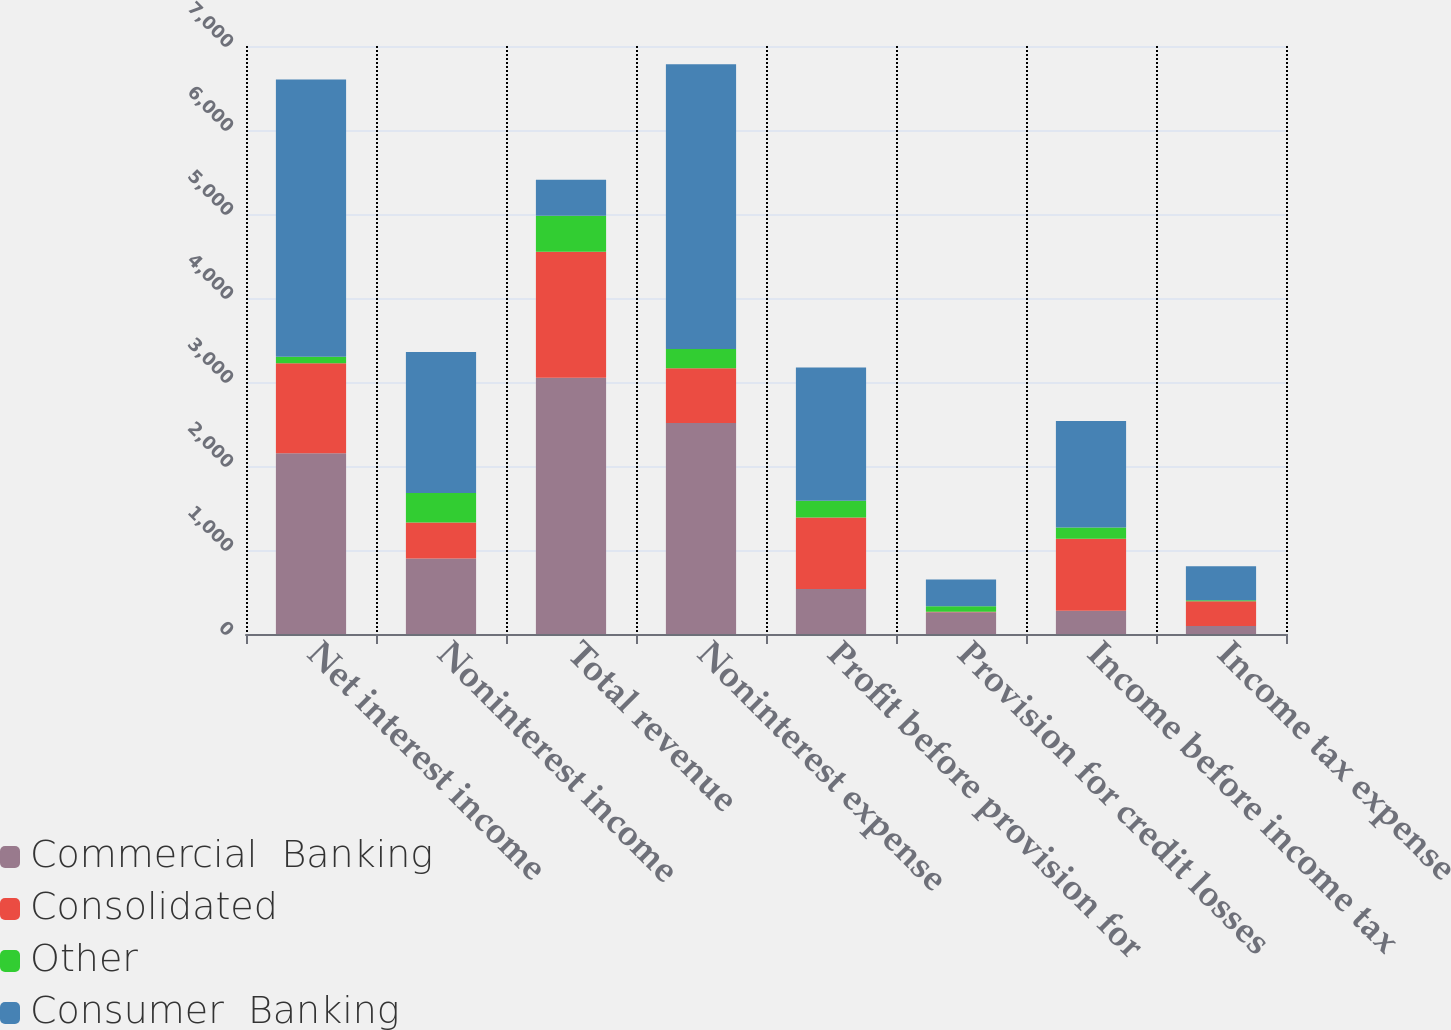<chart> <loc_0><loc_0><loc_500><loc_500><stacked_bar_chart><ecel><fcel>Net interest income<fcel>Noninterest income<fcel>Total revenue<fcel>Noninterest expense<fcel>Profit before provision for<fcel>Provision for credit losses<fcel>Income before income tax<fcel>Income tax expense<nl><fcel>Commercial  Banking<fcel>2151<fcel>899<fcel>3050<fcel>2513<fcel>537<fcel>259<fcel>278<fcel>96<nl><fcel>Consolidated<fcel>1073<fcel>429<fcel>1502<fcel>652<fcel>850<fcel>6<fcel>856<fcel>295<nl><fcel>Other<fcel>77<fcel>350<fcel>427<fcel>227<fcel>200<fcel>66<fcel>134<fcel>12<nl><fcel>Consumer  Banking<fcel>3301<fcel>1678<fcel>429<fcel>3392<fcel>1587<fcel>319<fcel>1268<fcel>403<nl></chart> 